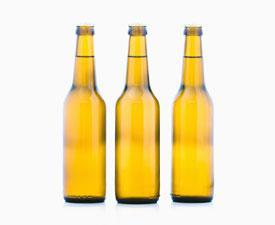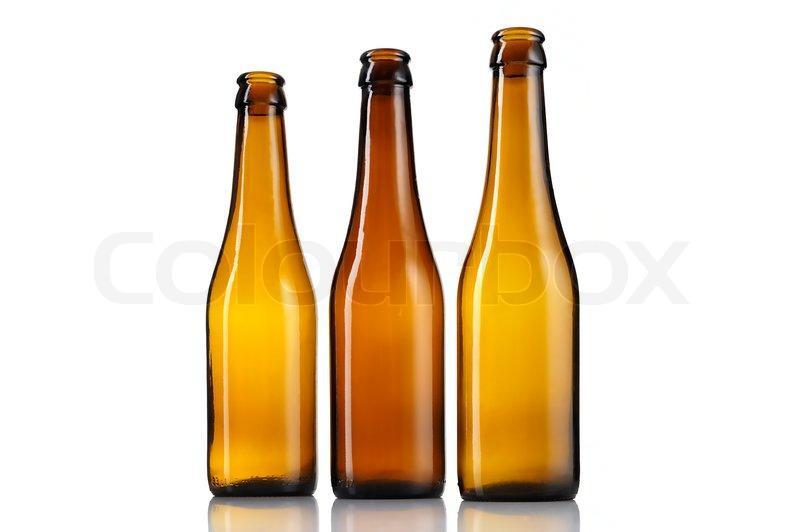The first image is the image on the left, the second image is the image on the right. For the images displayed, is the sentence "The bottles in the image on the right have no caps." factually correct? Answer yes or no. Yes. 